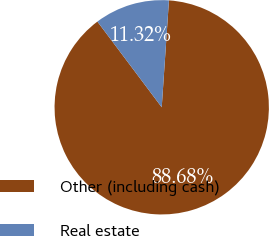<chart> <loc_0><loc_0><loc_500><loc_500><pie_chart><fcel>Other (including cash)<fcel>Real estate<nl><fcel>88.68%<fcel>11.32%<nl></chart> 